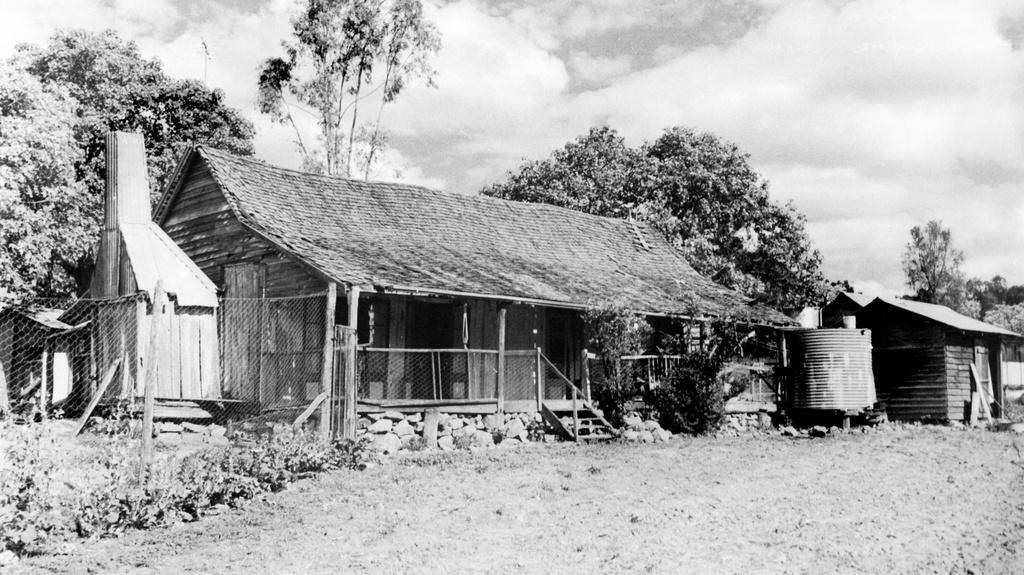Please provide a concise description of this image. This is a black and white picture and in the foreground of this image, there are huts, tank, trees, stones, plants, fencing, sky and the cloud. 